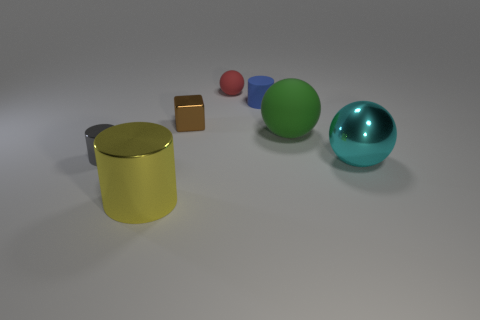Subtract all tiny cylinders. How many cylinders are left? 1 Subtract 1 spheres. How many spheres are left? 2 Add 2 cylinders. How many objects exist? 9 Subtract all cylinders. How many objects are left? 4 Subtract 0 red blocks. How many objects are left? 7 Subtract all blue things. Subtract all small shiny blocks. How many objects are left? 5 Add 4 tiny cylinders. How many tiny cylinders are left? 6 Add 5 large gray cubes. How many large gray cubes exist? 5 